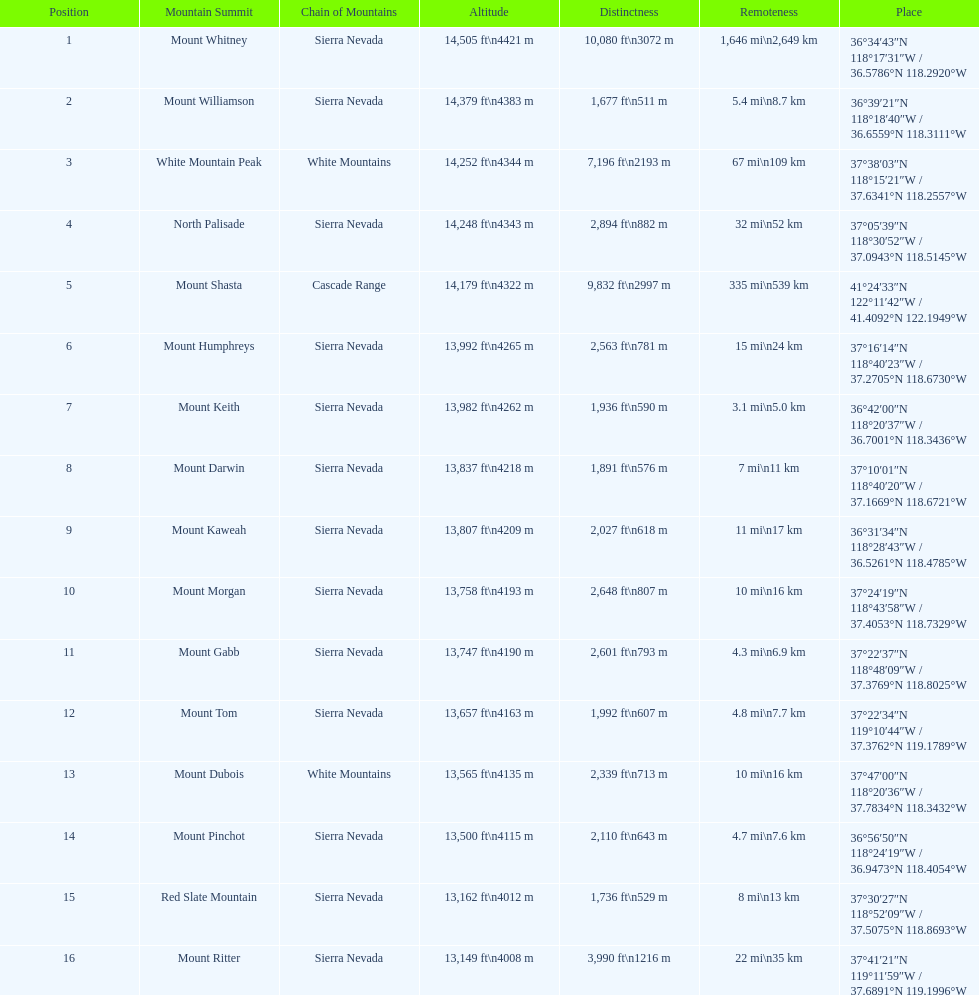In feet, what is the difference between the tallest peak and the 9th tallest peak in california? 698 ft. 